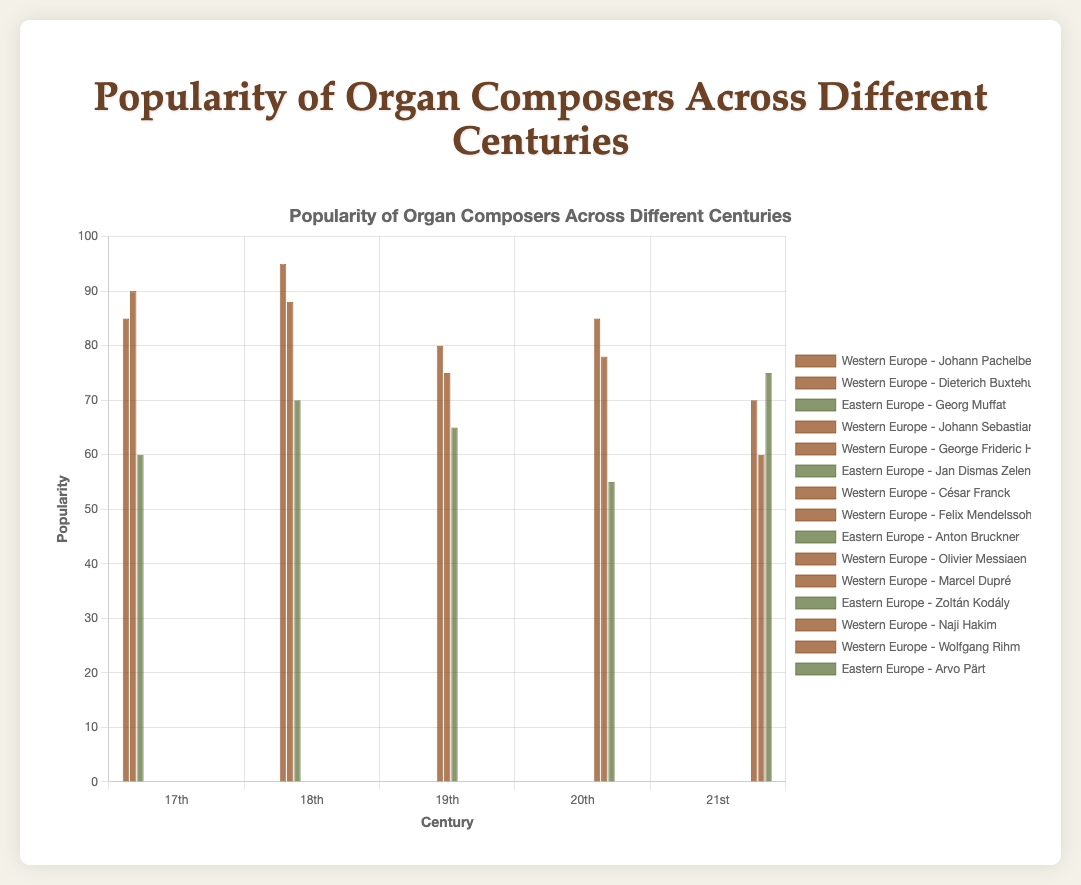Which composer has the highest popularity in the 18th century? In the 18th century, the composers listed are Johann Sebastian Bach (95) and George Frideric Handel (88) from Western Europe, and Jan Dismas Zelenka (70) from Eastern Europe. Bach has the highest popularity.
Answer: Johann Sebastian Bach How does the popularity of Johann Sebastian Bach compare to that of Johann Pachelbel? Johann Sebastian Bach has a popularity of 95, while Johann Pachelbel has a popularity of 85. Therefore, Bach is more popular than Pachelbel.
Answer: Johann Sebastian Bach is more popular What is the average popularity of Western European composers in the 19th century? The Western European composers in the 19th century are César Franck (80) and Felix Mendelssohn (75). The average is calculated as (80 + 75) / 2 = 77.5.
Answer: 77.5 Which region has more popular composers in the 20th century? In the 20th century, Western Europe has Olivier Messiaen (85) and Marcel Dupré (78), while Eastern Europe has Zoltán Kodály (55). Summing the popularities: Western Europe (85 + 78 = 163) and Eastern Europe (55). Western Europe has more popular composers.
Answer: Western Europe What is the difference in popularity between the most popular composer in the 17th century and the most popular composer in the 18th century? The most popular composer in the 17th century is Dieterich Buxtehude (90), and the most popular composer in the 18th century is Johann Sebastian Bach (95). The difference is 95 - 90 = 5.
Answer: 5 Which composer from Western Europe in the 20th century has a higher popularity, and by how much? In the 20th century, the Western European composers are Olivier Messiaen (85) and Marcel Dupré (78). Messiaen is more popular by 85 - 78 = 7.
Answer: Olivier Messiaen by 7 What is the total popularity of composers from Eastern Europe in the 18th and 19th centuries combined? Sum the popularities of Eastern European composers in the 18th century (Jan Dismas Zelenka: 70) and 19th century (Anton Bruckner: 65). The total is 70 + 65 = 135.
Answer: 135 